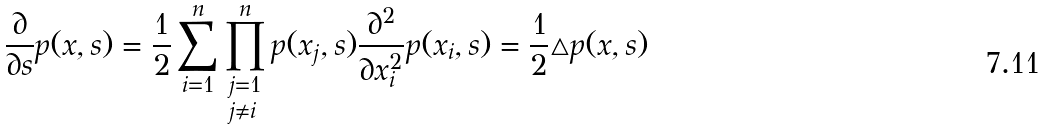<formula> <loc_0><loc_0><loc_500><loc_500>\frac { \partial } { \partial s } p ( x , s ) = \frac { 1 } { 2 } \sum _ { i = 1 } ^ { n } \prod ^ { n } _ { \begin{subarray} { c } j = 1 \\ j \neq i \end{subarray} } p ( x _ { j } , s ) \frac { \partial ^ { 2 } } { \partial x _ { i } ^ { 2 } } p ( x _ { i } , s ) = \frac { 1 } { 2 } \triangle p ( x , s )</formula> 